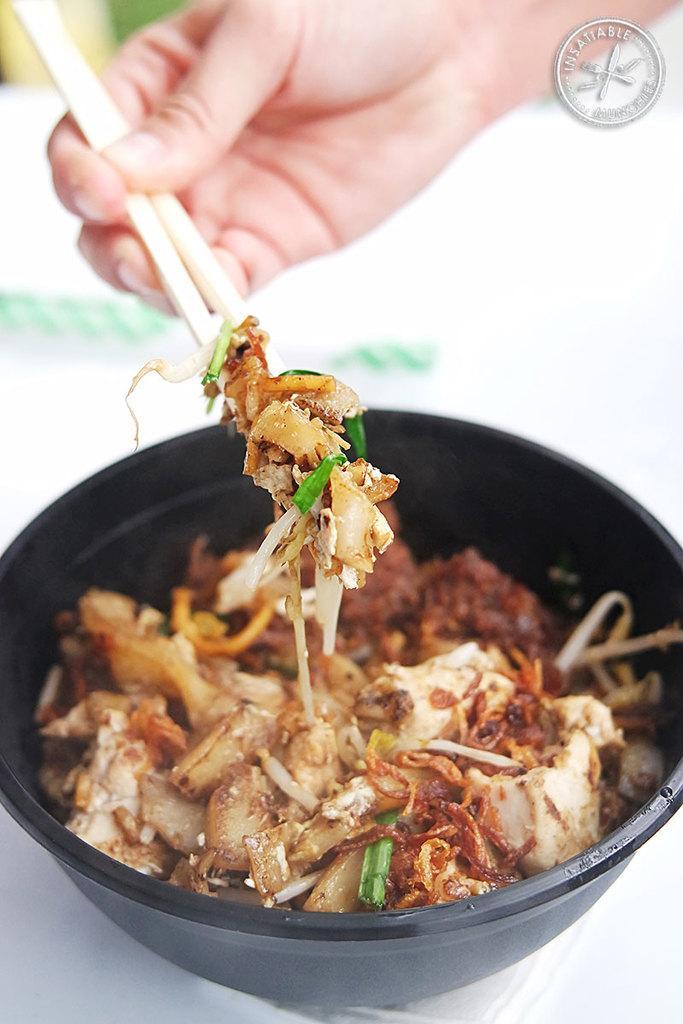How would you summarize this image in a sentence or two? In this image a person is holding chopsticks in his hand from a bowl having some food in it. At the right top corner there is an emblem. 